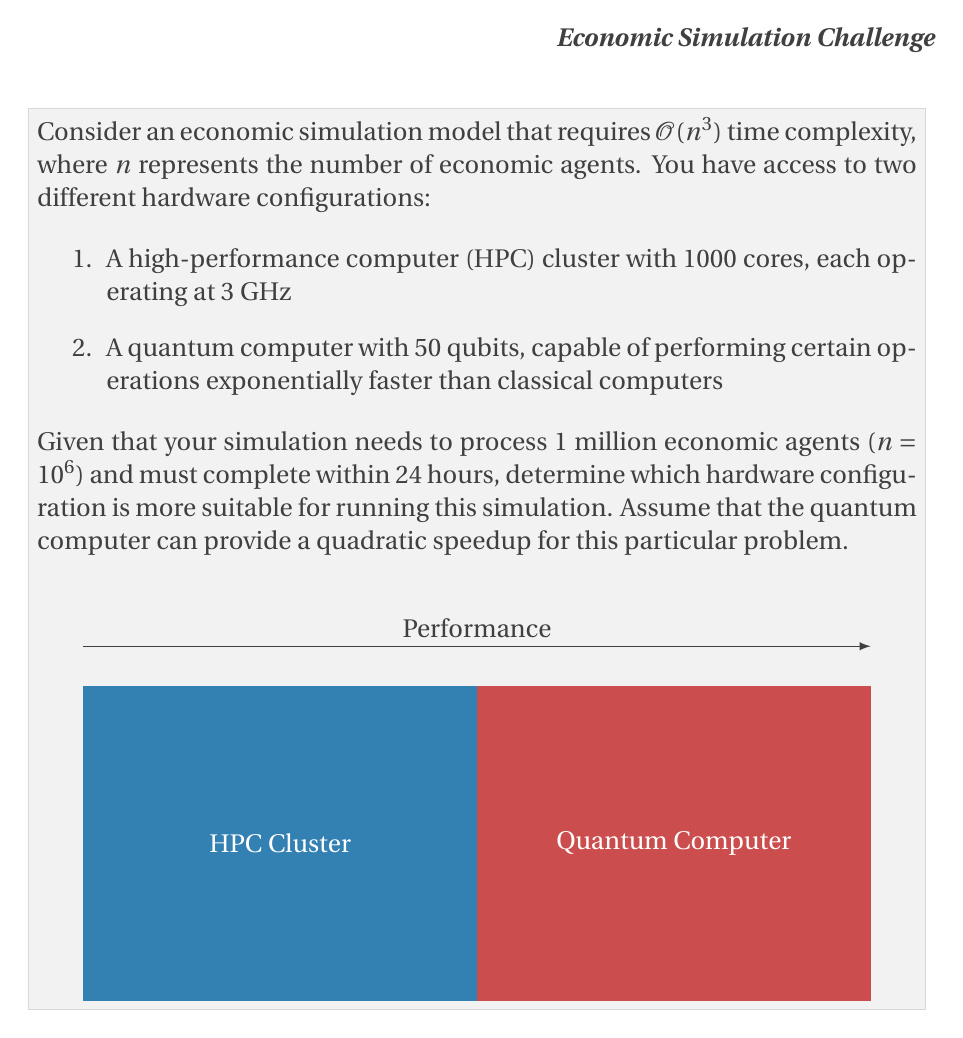What is the answer to this math problem? Let's approach this step-by-step:

1) First, let's calculate the number of operations required for the simulation:
   $$\text{Operations} = O(n^3) = O((10^6)^3) = O(10^{18})$$

2) For the HPC cluster:
   - Total processing power = 1000 cores × 3 GHz = 3000 GHz
   - Operations per second = 3000 × 10^9 = 3 × 10^{12}
   - Time to complete = $\frac{10^{18}}{3 \times 10^{12}} = 3.33 \times 10^5$ seconds
   - This is approximately 92.6 hours, which exceeds the 24-hour limit

3) For the quantum computer:
   - With a quadratic speedup, the time complexity reduces to $O(n^{3/2})$
   - Number of operations = $O((10^6)^{3/2}) = O(10^9)$
   - Even if the quantum computer processes only one operation per second, it would complete in $10^9$ seconds or about 31.7 years

4) However, we need to consider the actual processing power of the quantum computer:
   - With 50 qubits, it can theoretically perform $2^{50}$ operations simultaneously
   - Time to complete = $\frac{10^9}{2^{50}} \approx 8.88 \times 10^{-7}$ seconds

5) Comparing the two:
   - HPC Cluster: 92.6 hours
   - Quantum Computer: $8.88 \times 10^{-7}$ seconds

Even accounting for potential overheads and implementation challenges in quantum computing, the quantum computer is significantly faster and can complete the simulation well within the 24-hour limit.
Answer: The quantum computer is more suitable for running this simulation. 